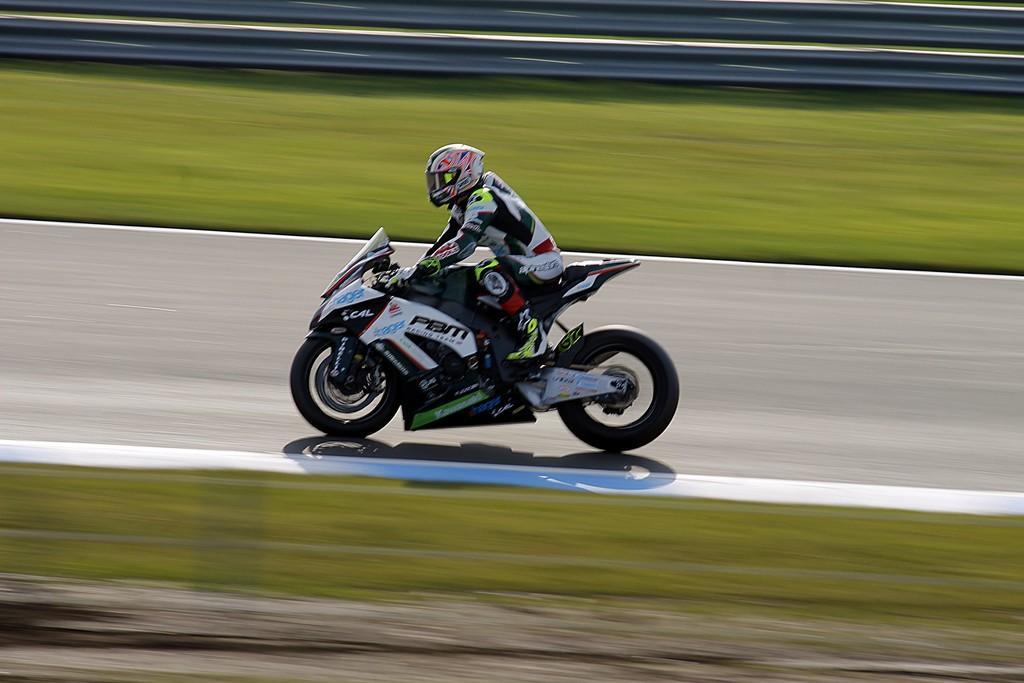How would you summarize this image in a sentence or two? In this image, I can see a person riding sports bike on the road. I think this is the glass. At the top of the image, It looks like the fence. 